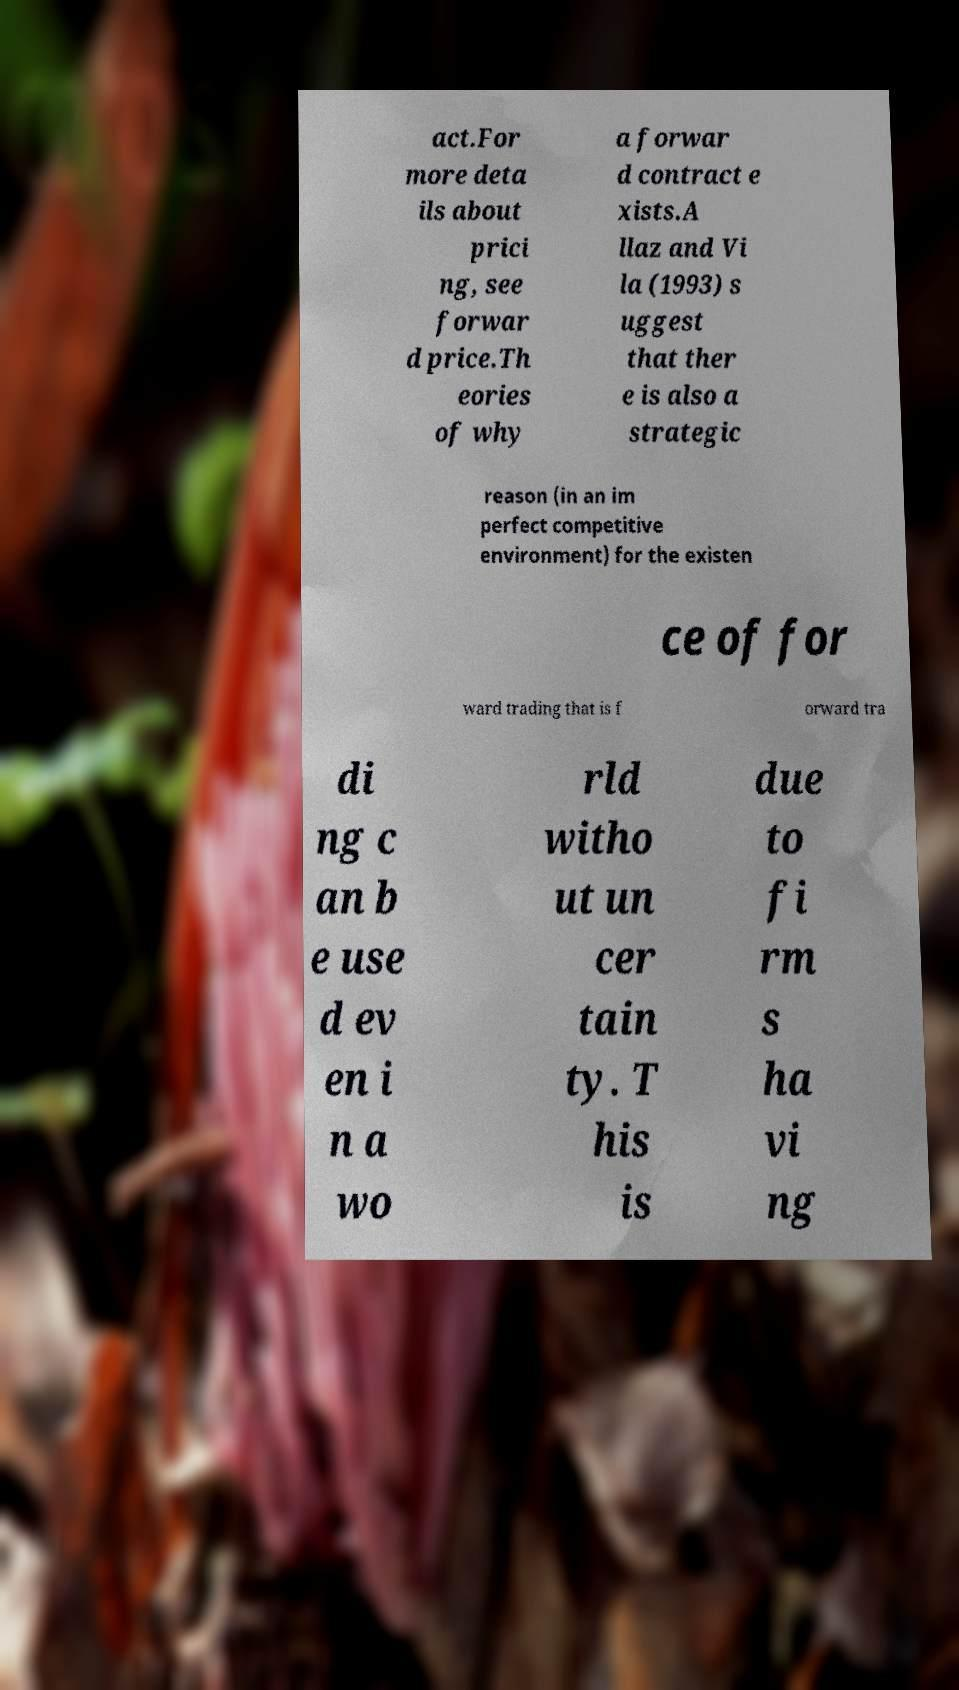Can you accurately transcribe the text from the provided image for me? act.For more deta ils about prici ng, see forwar d price.Th eories of why a forwar d contract e xists.A llaz and Vi la (1993) s uggest that ther e is also a strategic reason (in an im perfect competitive environment) for the existen ce of for ward trading that is f orward tra di ng c an b e use d ev en i n a wo rld witho ut un cer tain ty. T his is due to fi rm s ha vi ng 